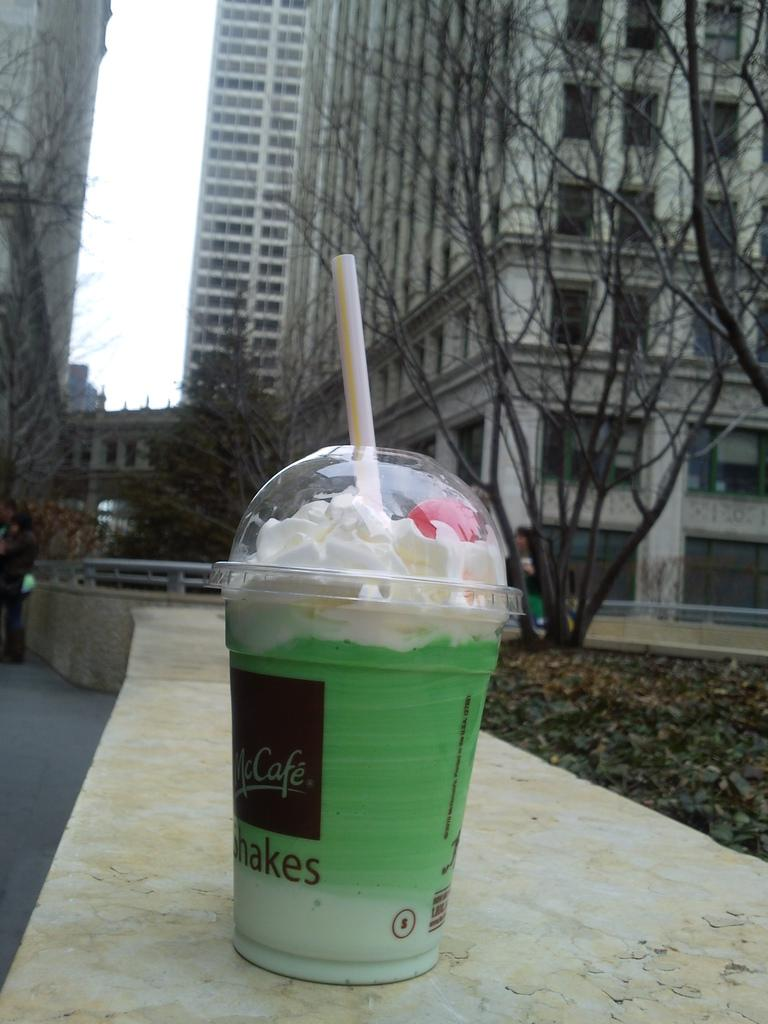What is the main subject in the center of the image? There is a glass of shake in the center of the image. What can be seen in the background of the image? There are trees and buildings in the background of the image. What type of basketball apparatus is visible in the image? There is no basketball apparatus present in the image. What language is spoken by the trees in the background? Trees do not speak any language, so this question cannot be answered. 